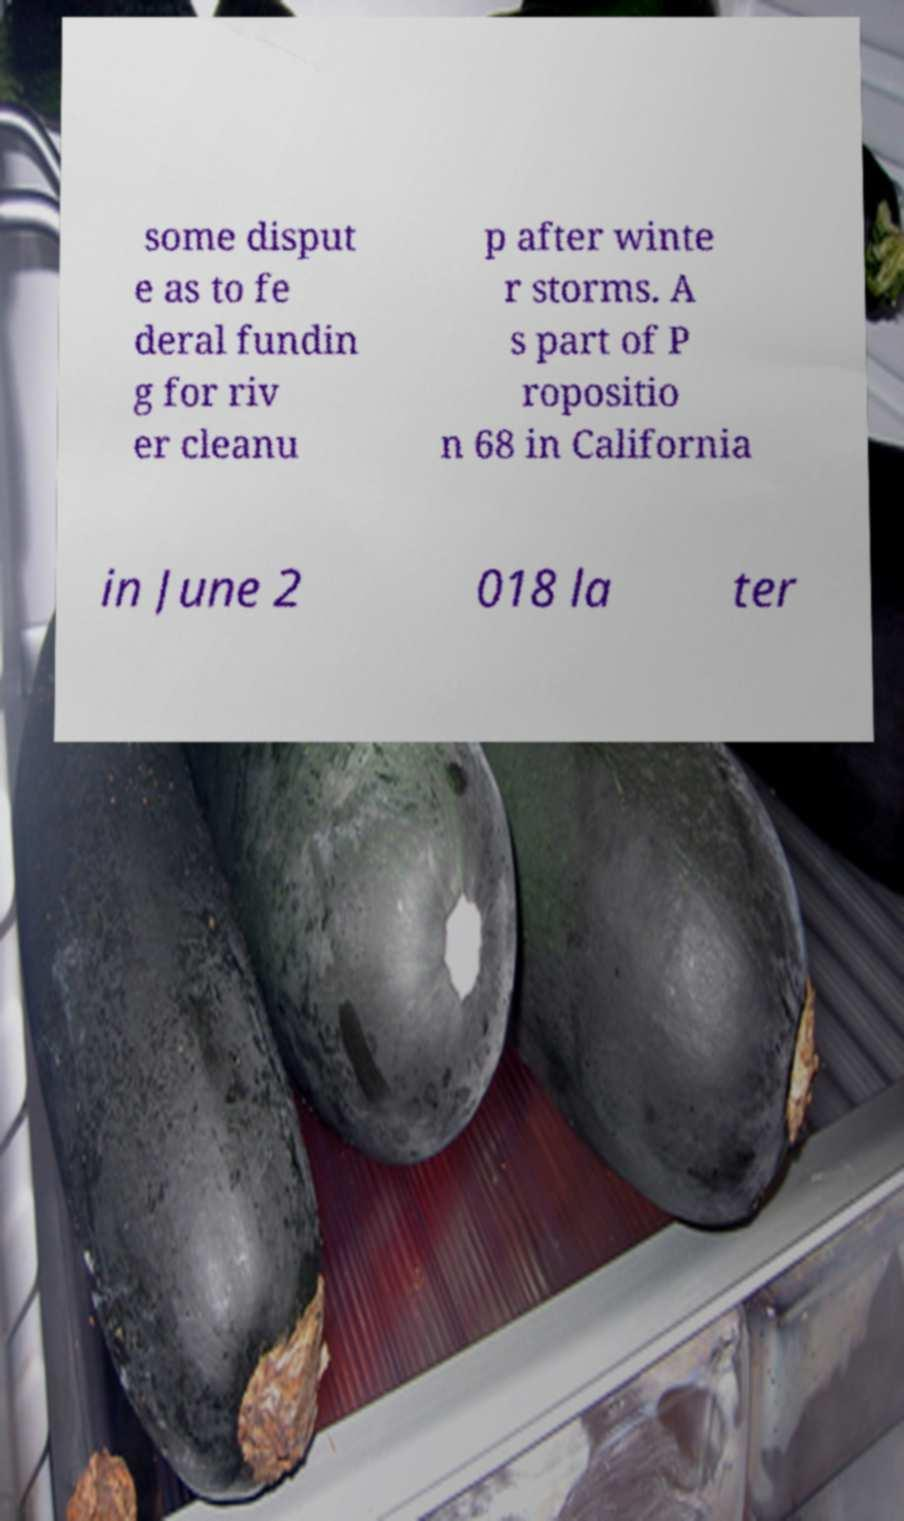Please identify and transcribe the text found in this image. some disput e as to fe deral fundin g for riv er cleanu p after winte r storms. A s part of P ropositio n 68 in California in June 2 018 la ter 